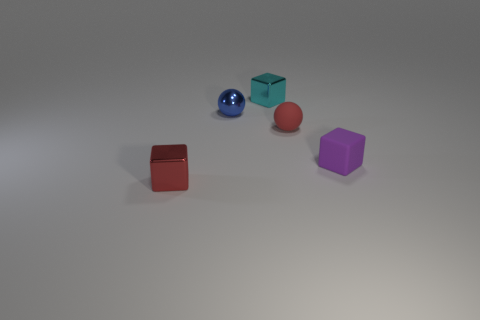What materials do the objects in the image appear to be made of? The objects in the image appear to be made of a smooth, matte material, commonly associated with plastic or coated metal, likely used for illustrative purposes or as play blocks. 